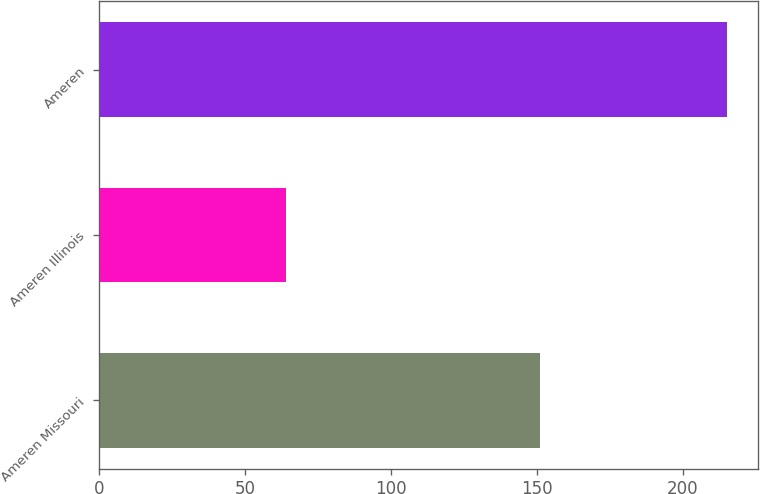<chart> <loc_0><loc_0><loc_500><loc_500><bar_chart><fcel>Ameren Missouri<fcel>Ameren Illinois<fcel>Ameren<nl><fcel>151<fcel>64<fcel>215<nl></chart> 